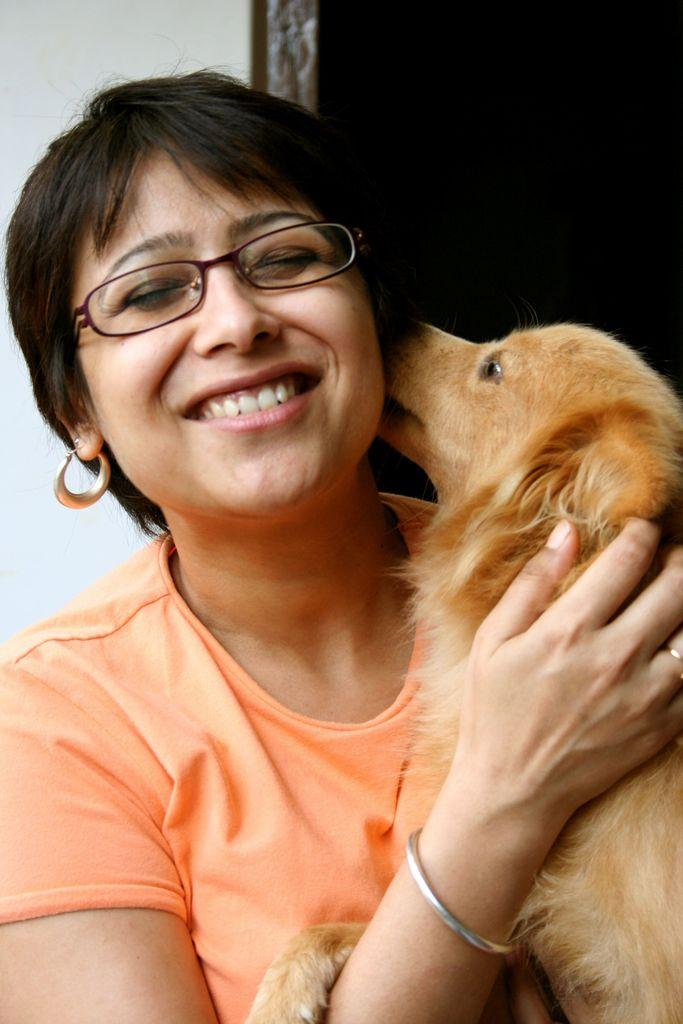Who is the main subject in the image? There is a woman in the image. What is the woman holding in the image? The woman is holding a dog. What is the woman's facial expression in the image? The woman is smiling. What type of eyewear is the woman wearing in the image? The woman is wearing glasses (specs). What color is the woman's top in the image? The woman is wearing an orange top. What type of advertisement is the woman promoting in the image? There is no advertisement present in the image; it simply features a woman holding a dog and smiling. 